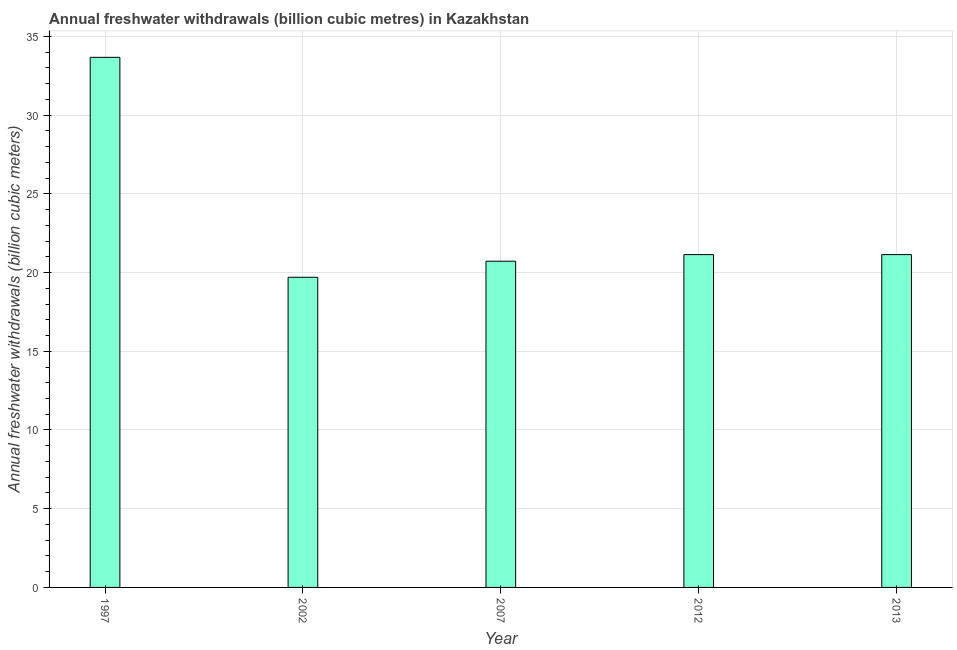What is the title of the graph?
Offer a very short reply. Annual freshwater withdrawals (billion cubic metres) in Kazakhstan. What is the label or title of the X-axis?
Ensure brevity in your answer.  Year. What is the label or title of the Y-axis?
Give a very brief answer. Annual freshwater withdrawals (billion cubic meters). What is the annual freshwater withdrawals in 2013?
Your response must be concise. 21.14. Across all years, what is the maximum annual freshwater withdrawals?
Your answer should be compact. 33.67. In which year was the annual freshwater withdrawals maximum?
Ensure brevity in your answer.  1997. In which year was the annual freshwater withdrawals minimum?
Make the answer very short. 2002. What is the sum of the annual freshwater withdrawals?
Provide a succinct answer. 116.37. What is the difference between the annual freshwater withdrawals in 2012 and 2013?
Make the answer very short. 0. What is the average annual freshwater withdrawals per year?
Ensure brevity in your answer.  23.27. What is the median annual freshwater withdrawals?
Your response must be concise. 21.14. Do a majority of the years between 2007 and 2013 (inclusive) have annual freshwater withdrawals greater than 23 billion cubic meters?
Your answer should be compact. No. What is the ratio of the annual freshwater withdrawals in 2002 to that in 2013?
Ensure brevity in your answer.  0.93. Is the annual freshwater withdrawals in 1997 less than that in 2007?
Provide a succinct answer. No. What is the difference between the highest and the second highest annual freshwater withdrawals?
Offer a very short reply. 12.53. What is the difference between the highest and the lowest annual freshwater withdrawals?
Your response must be concise. 13.97. How many years are there in the graph?
Give a very brief answer. 5. What is the Annual freshwater withdrawals (billion cubic meters) of 1997?
Offer a terse response. 33.67. What is the Annual freshwater withdrawals (billion cubic meters) of 2007?
Offer a terse response. 20.72. What is the Annual freshwater withdrawals (billion cubic meters) of 2012?
Keep it short and to the point. 21.14. What is the Annual freshwater withdrawals (billion cubic meters) of 2013?
Keep it short and to the point. 21.14. What is the difference between the Annual freshwater withdrawals (billion cubic meters) in 1997 and 2002?
Keep it short and to the point. 13.97. What is the difference between the Annual freshwater withdrawals (billion cubic meters) in 1997 and 2007?
Offer a terse response. 12.95. What is the difference between the Annual freshwater withdrawals (billion cubic meters) in 1997 and 2012?
Ensure brevity in your answer.  12.53. What is the difference between the Annual freshwater withdrawals (billion cubic meters) in 1997 and 2013?
Your answer should be very brief. 12.53. What is the difference between the Annual freshwater withdrawals (billion cubic meters) in 2002 and 2007?
Your answer should be compact. -1.02. What is the difference between the Annual freshwater withdrawals (billion cubic meters) in 2002 and 2012?
Give a very brief answer. -1.44. What is the difference between the Annual freshwater withdrawals (billion cubic meters) in 2002 and 2013?
Your answer should be very brief. -1.44. What is the difference between the Annual freshwater withdrawals (billion cubic meters) in 2007 and 2012?
Keep it short and to the point. -0.42. What is the difference between the Annual freshwater withdrawals (billion cubic meters) in 2007 and 2013?
Give a very brief answer. -0.42. What is the ratio of the Annual freshwater withdrawals (billion cubic meters) in 1997 to that in 2002?
Offer a terse response. 1.71. What is the ratio of the Annual freshwater withdrawals (billion cubic meters) in 1997 to that in 2007?
Give a very brief answer. 1.62. What is the ratio of the Annual freshwater withdrawals (billion cubic meters) in 1997 to that in 2012?
Make the answer very short. 1.59. What is the ratio of the Annual freshwater withdrawals (billion cubic meters) in 1997 to that in 2013?
Your response must be concise. 1.59. What is the ratio of the Annual freshwater withdrawals (billion cubic meters) in 2002 to that in 2007?
Offer a very short reply. 0.95. What is the ratio of the Annual freshwater withdrawals (billion cubic meters) in 2002 to that in 2012?
Your answer should be compact. 0.93. What is the ratio of the Annual freshwater withdrawals (billion cubic meters) in 2002 to that in 2013?
Provide a short and direct response. 0.93. What is the ratio of the Annual freshwater withdrawals (billion cubic meters) in 2012 to that in 2013?
Provide a succinct answer. 1. 